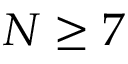Convert formula to latex. <formula><loc_0><loc_0><loc_500><loc_500>N \geq 7</formula> 